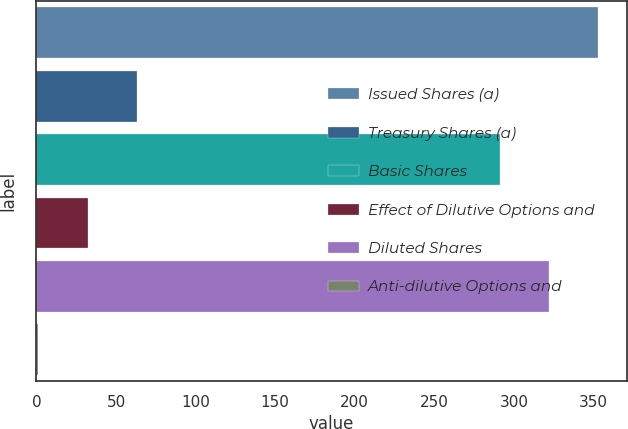Convert chart. <chart><loc_0><loc_0><loc_500><loc_500><bar_chart><fcel>Issued Shares (a)<fcel>Treasury Shares (a)<fcel>Basic Shares<fcel>Effect of Dilutive Options and<fcel>Diluted Shares<fcel>Anti-dilutive Options and<nl><fcel>353.2<fcel>63.2<fcel>291<fcel>32.1<fcel>322.1<fcel>1<nl></chart> 